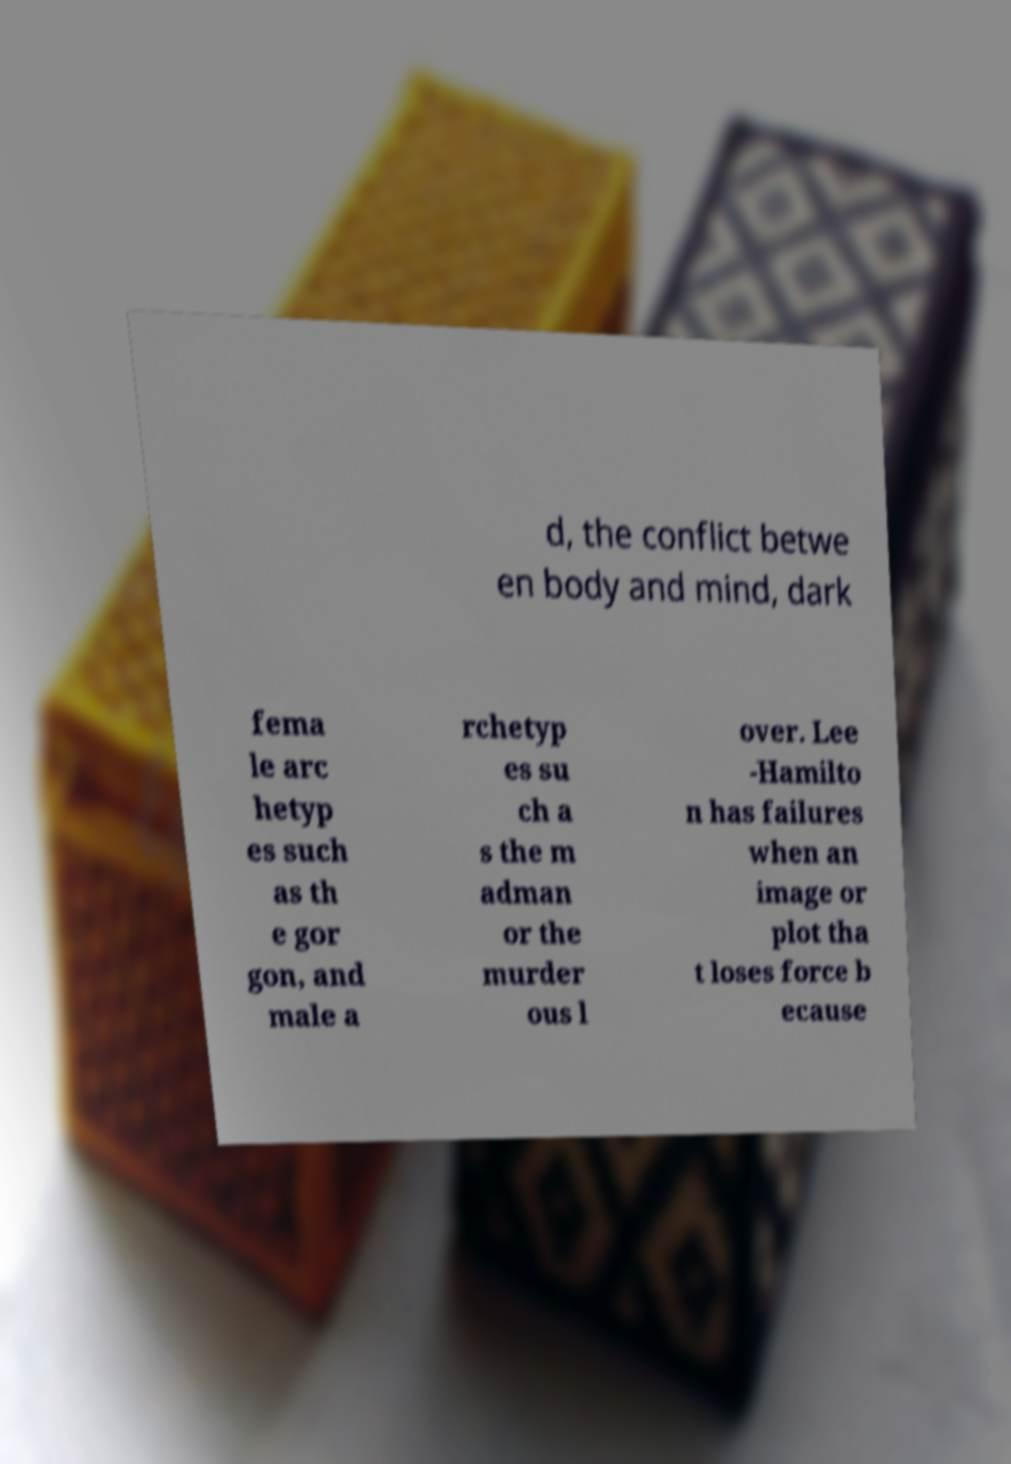Please read and relay the text visible in this image. What does it say? d, the conflict betwe en body and mind, dark fema le arc hetyp es such as th e gor gon, and male a rchetyp es su ch a s the m adman or the murder ous l over. Lee -Hamilto n has failures when an image or plot tha t loses force b ecause 